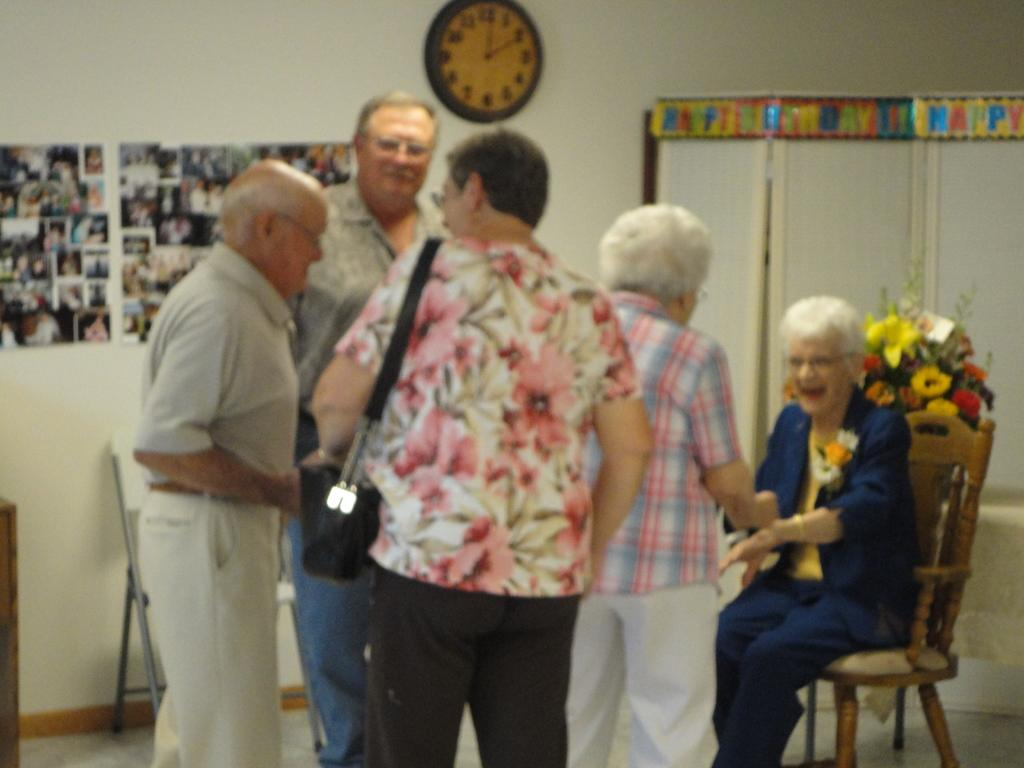<image>
Relay a brief, clear account of the picture shown. A group of people gathered in a room with photos on the wall, a wall clock indicates that it is two o clock. 